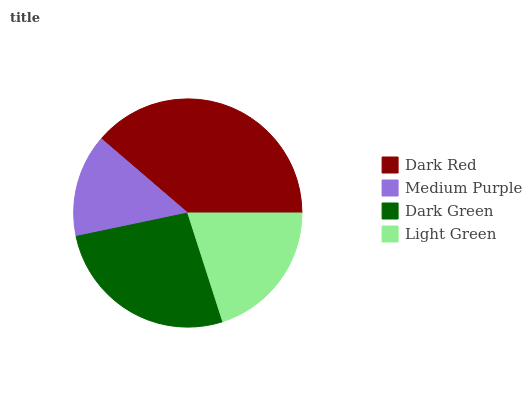Is Medium Purple the minimum?
Answer yes or no. Yes. Is Dark Red the maximum?
Answer yes or no. Yes. Is Dark Green the minimum?
Answer yes or no. No. Is Dark Green the maximum?
Answer yes or no. No. Is Dark Green greater than Medium Purple?
Answer yes or no. Yes. Is Medium Purple less than Dark Green?
Answer yes or no. Yes. Is Medium Purple greater than Dark Green?
Answer yes or no. No. Is Dark Green less than Medium Purple?
Answer yes or no. No. Is Dark Green the high median?
Answer yes or no. Yes. Is Light Green the low median?
Answer yes or no. Yes. Is Medium Purple the high median?
Answer yes or no. No. Is Medium Purple the low median?
Answer yes or no. No. 